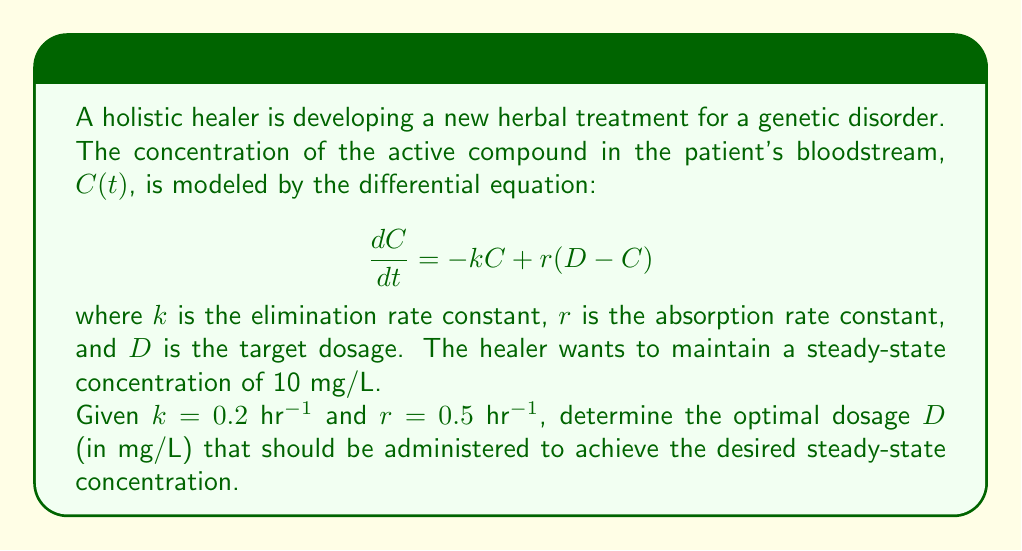Solve this math problem. To solve this problem, we'll follow these steps:

1) At steady-state, the concentration doesn't change over time, so $\frac{dC}{dt} = 0$.

2) Substitute this into the differential equation:

   $$0 = -kC + r(D - C)$$

3) We're given that the desired steady-state concentration is 10 mg/L, so let $C = 10$:

   $$0 = -k(10) + r(D - 10)$$

4) Substitute the given values for $k$ and $r$:

   $$0 = -0.2(10) + 0.5(D - 10)$$

5) Simplify:

   $$0 = -2 + 0.5D - 5$$
   $$0 = 0.5D - 7$$

6) Solve for $D$:

   $$0.5D = 7$$
   $$D = 14$$

Therefore, the optimal dosage $D$ is 14 mg/L.
Answer: $D = 14$ mg/L 